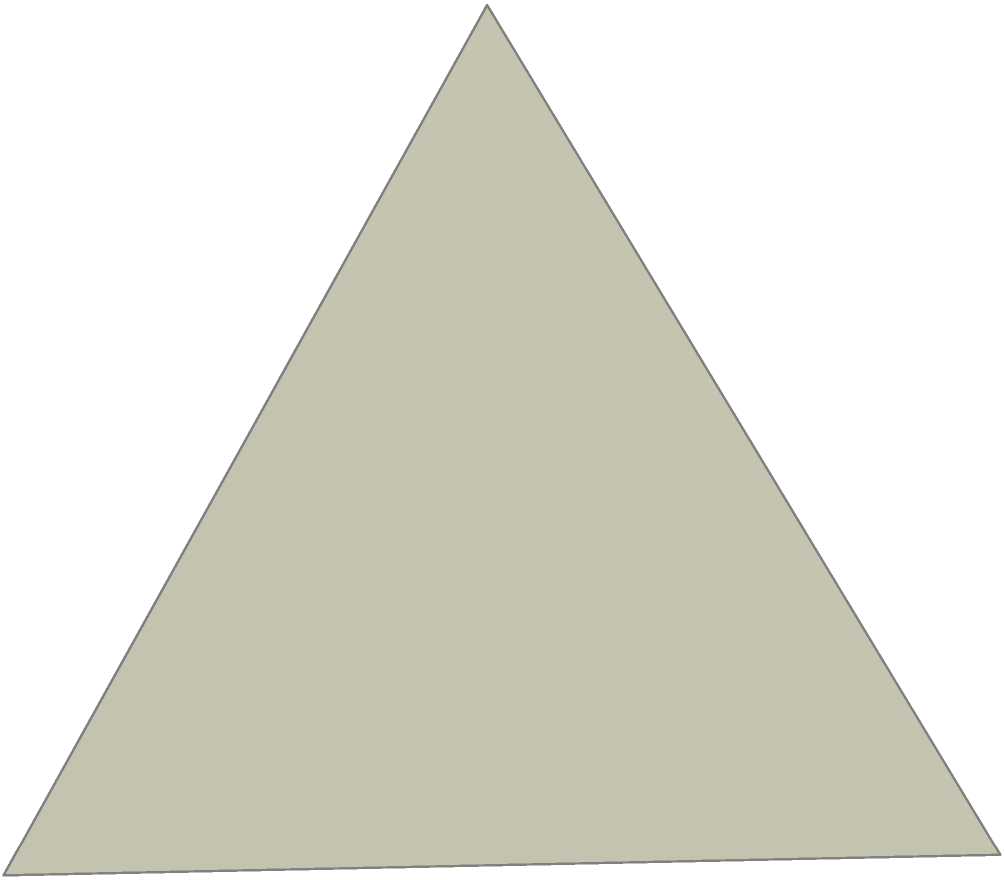As a graphic designer, you're tasked with creating a 3D model of an octahedron for a client's logo. The client specifies that each edge of the octahedron should be 10 cm long. To accurately render the model, you need to calculate its surface area. Given that the edge length $a$ is 10 cm, what is the total surface area of the regular octahedron? Let's approach this step-by-step:

1) A regular octahedron consists of 8 equilateral triangular faces.

2) To find the surface area, we need to calculate the area of one triangular face and multiply it by 8.

3) The area of an equilateral triangle with side length $a$ is given by:

   $$A_{\text{triangle}} = \frac{\sqrt{3}}{4}a^2$$

4) Substituting $a = 10$ cm:

   $$A_{\text{triangle}} = \frac{\sqrt{3}}{4}(10)^2 = 25\sqrt{3} \text{ cm}^2$$

5) The total surface area is 8 times this:

   $$A_{\text{total}} = 8 \times 25\sqrt{3} = 200\sqrt{3} \text{ cm}^2$$

6) This can be simplified to:

   $$A_{\text{total}} = 200\sqrt{3} \approx 346.41 \text{ cm}^2$$

As a self-reliant graphic designer, you can now accurately render the octahedron for your client's logo, knowing its precise surface area.
Answer: $200\sqrt{3} \text{ cm}^2$ or approximately $346.41 \text{ cm}^2$ 